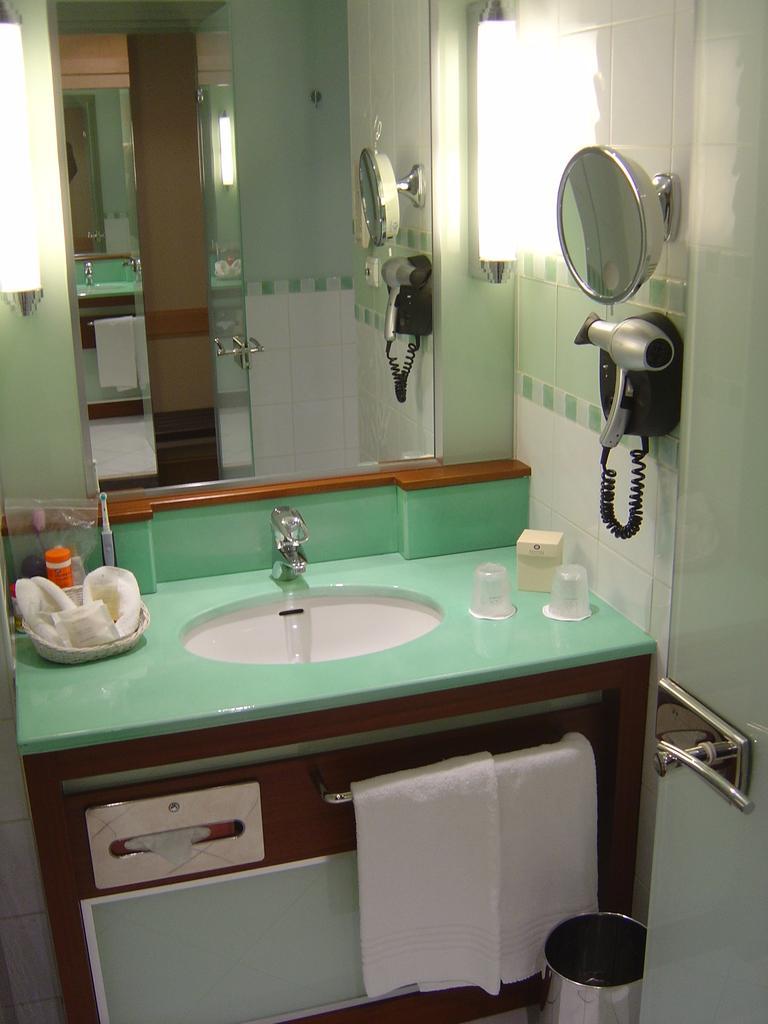Could you give a brief overview of what you see in this image? This is a picture of a room, we can see a mirror, glasses, clothes, sink and some other objects, on the left side of the image it looks like a hair dryer and a mirror on the wall, also we can see the lights and a door. 